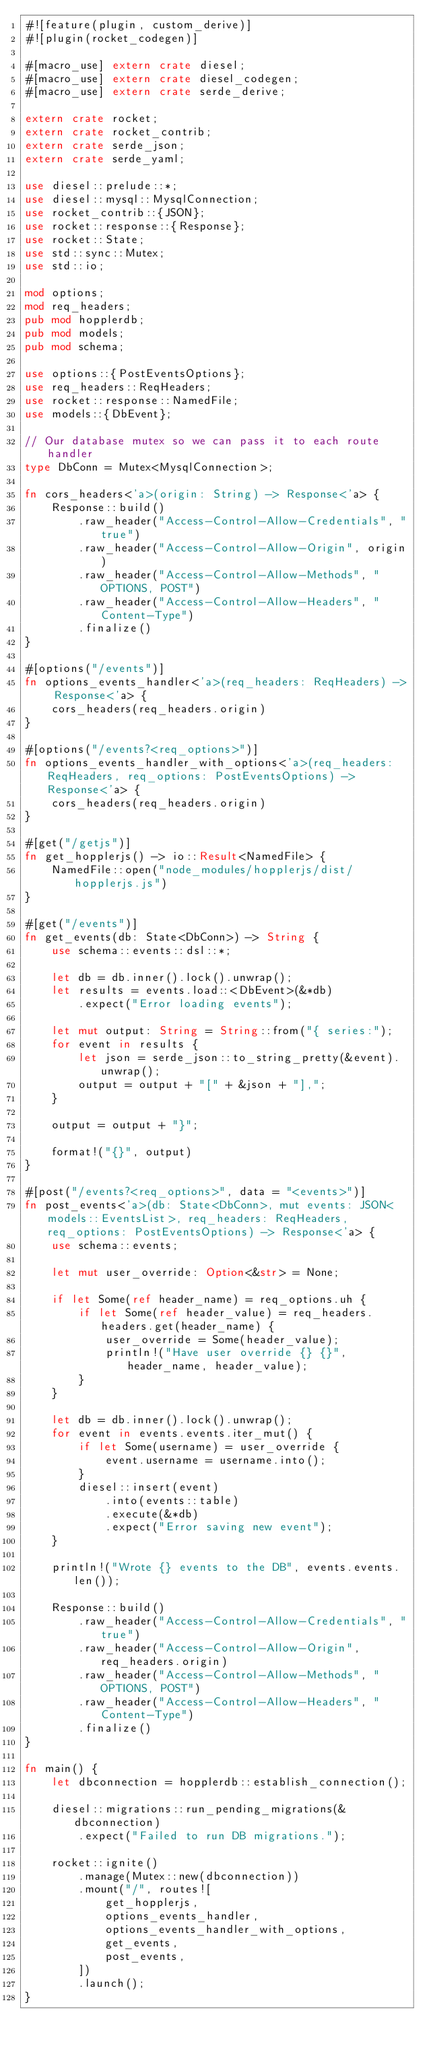<code> <loc_0><loc_0><loc_500><loc_500><_Rust_>#![feature(plugin, custom_derive)]
#![plugin(rocket_codegen)]

#[macro_use] extern crate diesel;
#[macro_use] extern crate diesel_codegen;
#[macro_use] extern crate serde_derive;

extern crate rocket;
extern crate rocket_contrib;
extern crate serde_json;
extern crate serde_yaml;

use diesel::prelude::*;
use diesel::mysql::MysqlConnection;
use rocket_contrib::{JSON};
use rocket::response::{Response};
use rocket::State;
use std::sync::Mutex;
use std::io;

mod options;
mod req_headers;
pub mod hopplerdb;
pub mod models;
pub mod schema;

use options::{PostEventsOptions};
use req_headers::ReqHeaders;
use rocket::response::NamedFile;
use models::{DbEvent};

// Our database mutex so we can pass it to each route handler
type DbConn = Mutex<MysqlConnection>;

fn cors_headers<'a>(origin: String) -> Response<'a> {
    Response::build()
        .raw_header("Access-Control-Allow-Credentials", "true")
        .raw_header("Access-Control-Allow-Origin", origin)
        .raw_header("Access-Control-Allow-Methods", "OPTIONS, POST")
        .raw_header("Access-Control-Allow-Headers", "Content-Type")
        .finalize()
}

#[options("/events")]
fn options_events_handler<'a>(req_headers: ReqHeaders) -> Response<'a> {
    cors_headers(req_headers.origin)
}

#[options("/events?<req_options>")]
fn options_events_handler_with_options<'a>(req_headers: ReqHeaders, req_options: PostEventsOptions) -> Response<'a> {
    cors_headers(req_headers.origin)
}

#[get("/getjs")]
fn get_hopplerjs() -> io::Result<NamedFile> {
    NamedFile::open("node_modules/hopplerjs/dist/hopplerjs.js")
}

#[get("/events")]
fn get_events(db: State<DbConn>) -> String {
    use schema::events::dsl::*;

    let db = db.inner().lock().unwrap();
    let results = events.load::<DbEvent>(&*db)
        .expect("Error loading events");

    let mut output: String = String::from("{ series:");
    for event in results {
        let json = serde_json::to_string_pretty(&event).unwrap();
        output = output + "[" + &json + "],";
    }

    output = output + "}";

    format!("{}", output)
}

#[post("/events?<req_options>", data = "<events>")]
fn post_events<'a>(db: State<DbConn>, mut events: JSON<models::EventsList>, req_headers: ReqHeaders, req_options: PostEventsOptions) -> Response<'a> {
    use schema::events;

    let mut user_override: Option<&str> = None;

    if let Some(ref header_name) = req_options.uh {
        if let Some(ref header_value) = req_headers.headers.get(header_name) {
            user_override = Some(header_value);
            println!("Have user override {} {}", header_name, header_value);
        }
    }

    let db = db.inner().lock().unwrap();
    for event in events.events.iter_mut() {
        if let Some(username) = user_override {
            event.username = username.into();
        }
        diesel::insert(event)
            .into(events::table)
            .execute(&*db)
            .expect("Error saving new event");
    }

    println!("Wrote {} events to the DB", events.events.len());

    Response::build()
        .raw_header("Access-Control-Allow-Credentials", "true")
        .raw_header("Access-Control-Allow-Origin", req_headers.origin)
        .raw_header("Access-Control-Allow-Methods", "OPTIONS, POST")
        .raw_header("Access-Control-Allow-Headers", "Content-Type")
        .finalize()
}

fn main() {
    let dbconnection = hopplerdb::establish_connection();

    diesel::migrations::run_pending_migrations(&dbconnection)
        .expect("Failed to run DB migrations.");

    rocket::ignite()
        .manage(Mutex::new(dbconnection))
        .mount("/", routes![
            get_hopplerjs,
            options_events_handler,
            options_events_handler_with_options,
            get_events,
            post_events,
        ])
        .launch();
}
</code> 